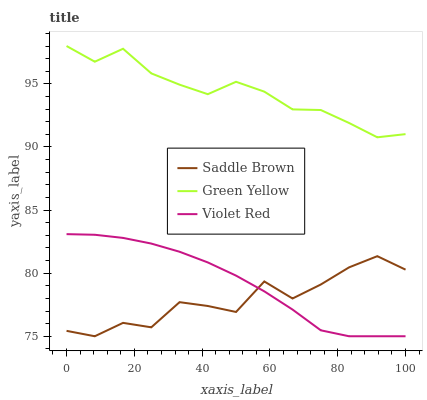Does Saddle Brown have the minimum area under the curve?
Answer yes or no. Yes. Does Green Yellow have the maximum area under the curve?
Answer yes or no. Yes. Does Green Yellow have the minimum area under the curve?
Answer yes or no. No. Does Saddle Brown have the maximum area under the curve?
Answer yes or no. No. Is Violet Red the smoothest?
Answer yes or no. Yes. Is Saddle Brown the roughest?
Answer yes or no. Yes. Is Green Yellow the smoothest?
Answer yes or no. No. Is Green Yellow the roughest?
Answer yes or no. No. Does Violet Red have the lowest value?
Answer yes or no. Yes. Does Green Yellow have the lowest value?
Answer yes or no. No. Does Green Yellow have the highest value?
Answer yes or no. Yes. Does Saddle Brown have the highest value?
Answer yes or no. No. Is Violet Red less than Green Yellow?
Answer yes or no. Yes. Is Green Yellow greater than Violet Red?
Answer yes or no. Yes. Does Saddle Brown intersect Violet Red?
Answer yes or no. Yes. Is Saddle Brown less than Violet Red?
Answer yes or no. No. Is Saddle Brown greater than Violet Red?
Answer yes or no. No. Does Violet Red intersect Green Yellow?
Answer yes or no. No. 